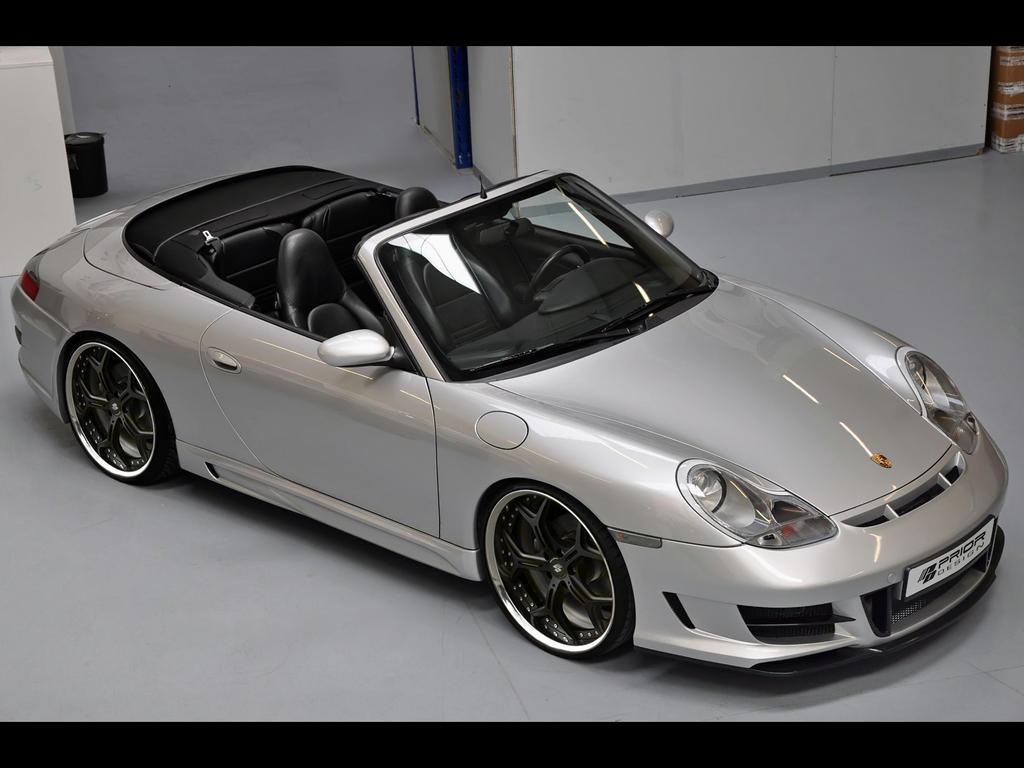In one or two sentences, can you explain what this image depicts? In this image I can see car on the ground. Here I can see black color object and white color wall. 